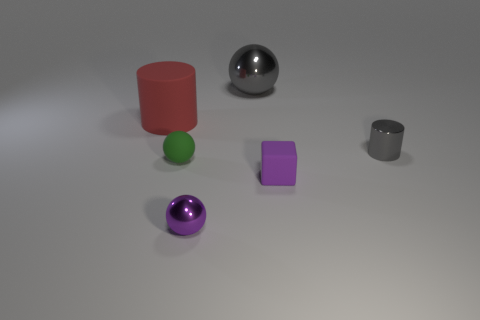Subtract all cyan balls. Subtract all red cubes. How many balls are left? 3 Add 3 large red things. How many objects exist? 9 Subtract all cubes. How many objects are left? 5 Add 1 small things. How many small things are left? 5 Add 1 tiny rubber objects. How many tiny rubber objects exist? 3 Subtract 1 purple cubes. How many objects are left? 5 Subtract all tiny cyan shiny spheres. Subtract all blocks. How many objects are left? 5 